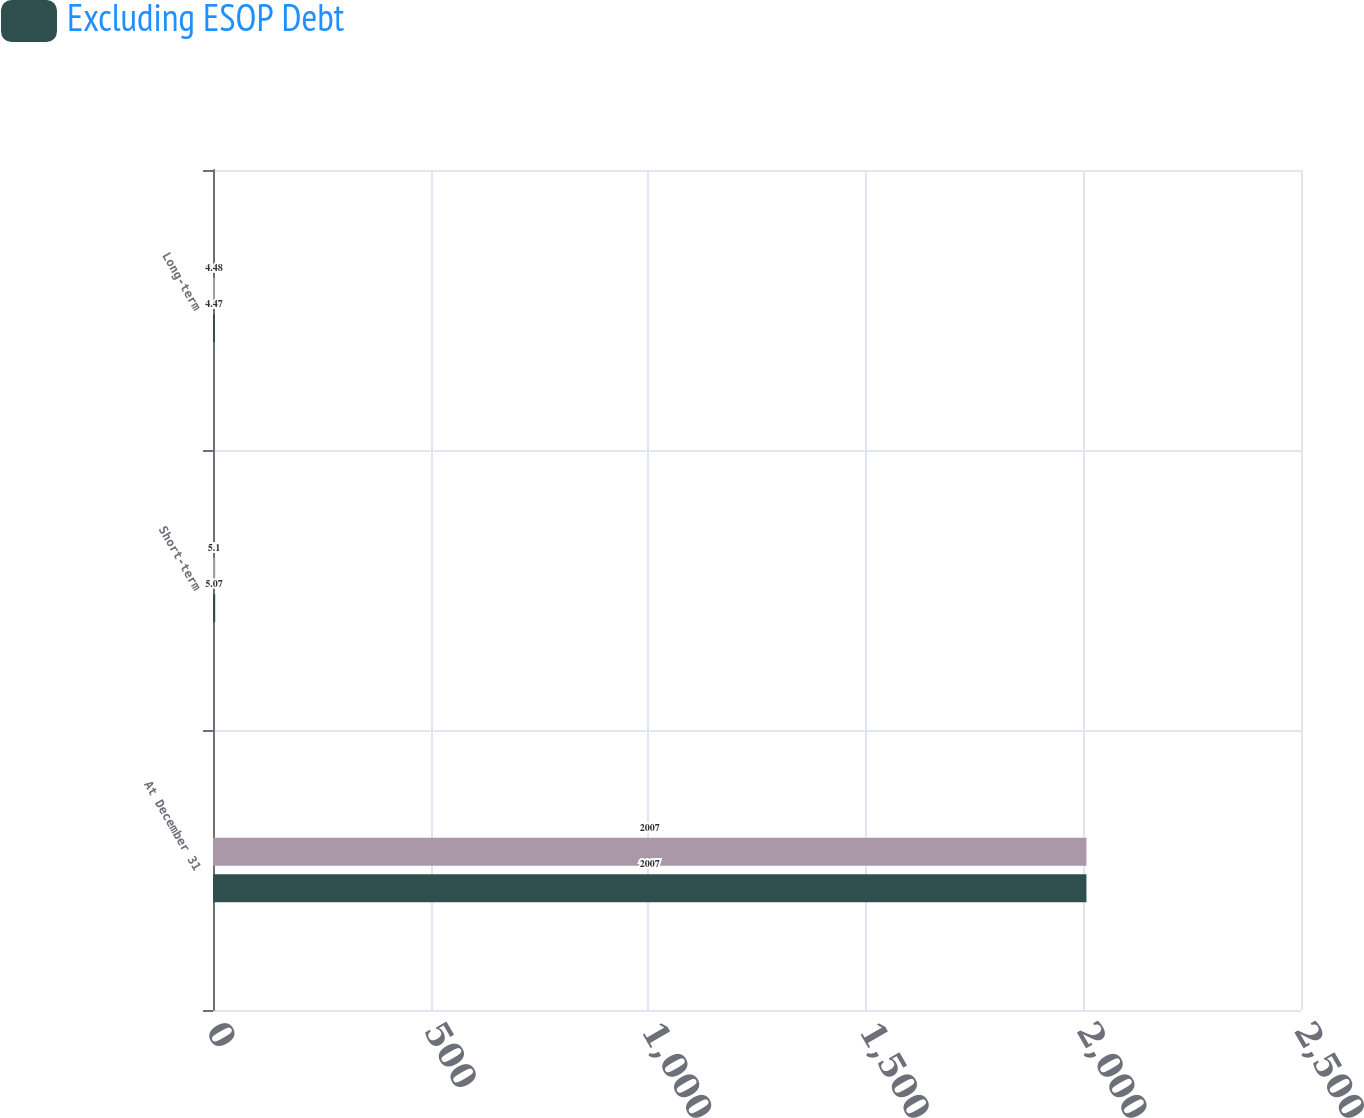<chart> <loc_0><loc_0><loc_500><loc_500><stacked_bar_chart><ecel><fcel>At December 31<fcel>Short-term<fcel>Long-term<nl><fcel>nan<fcel>2007<fcel>5.1<fcel>4.48<nl><fcel>Excluding ESOP Debt<fcel>2007<fcel>5.07<fcel>4.47<nl></chart> 